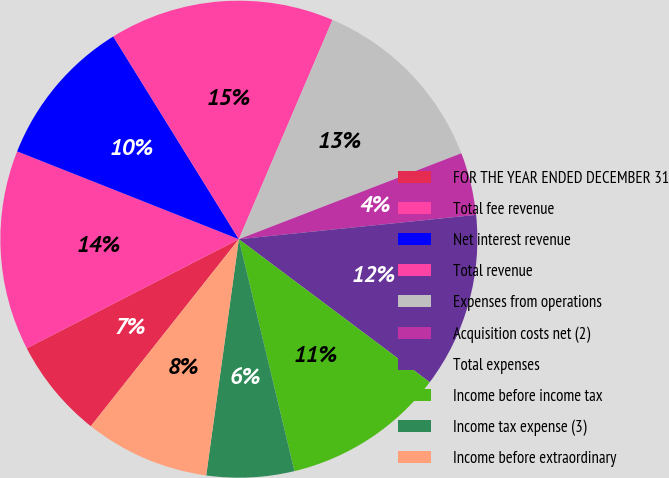<chart> <loc_0><loc_0><loc_500><loc_500><pie_chart><fcel>FOR THE YEAR ENDED DECEMBER 31<fcel>Total fee revenue<fcel>Net interest revenue<fcel>Total revenue<fcel>Expenses from operations<fcel>Acquisition costs net (2)<fcel>Total expenses<fcel>Income before income tax<fcel>Income tax expense (3)<fcel>Income before extraordinary<nl><fcel>6.78%<fcel>13.56%<fcel>10.17%<fcel>15.25%<fcel>12.71%<fcel>4.24%<fcel>11.86%<fcel>11.02%<fcel>5.93%<fcel>8.47%<nl></chart> 